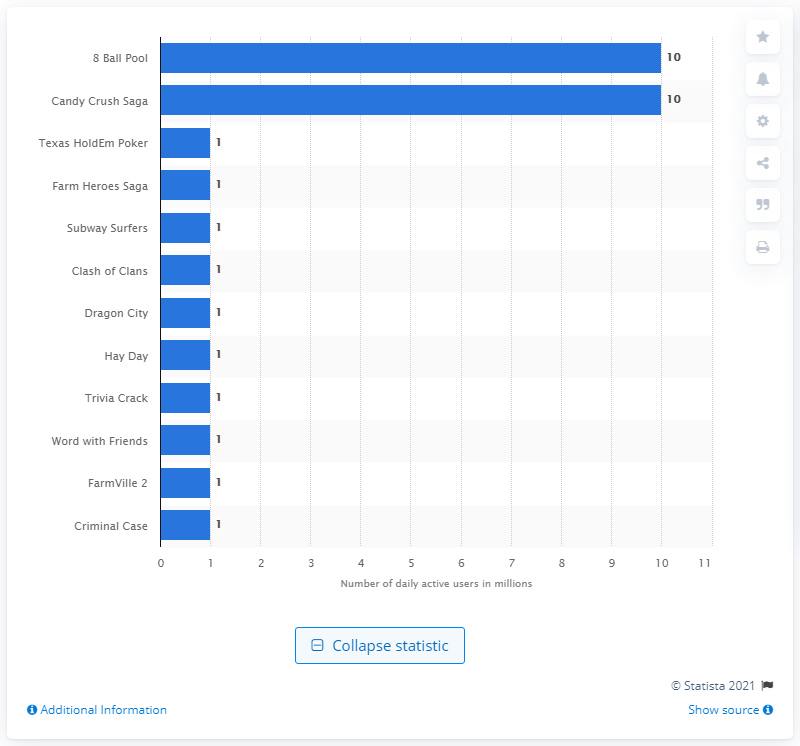Give some essential details in this illustration. In 2019, Candy Crush Saga had approximately 10 million daily active users. 